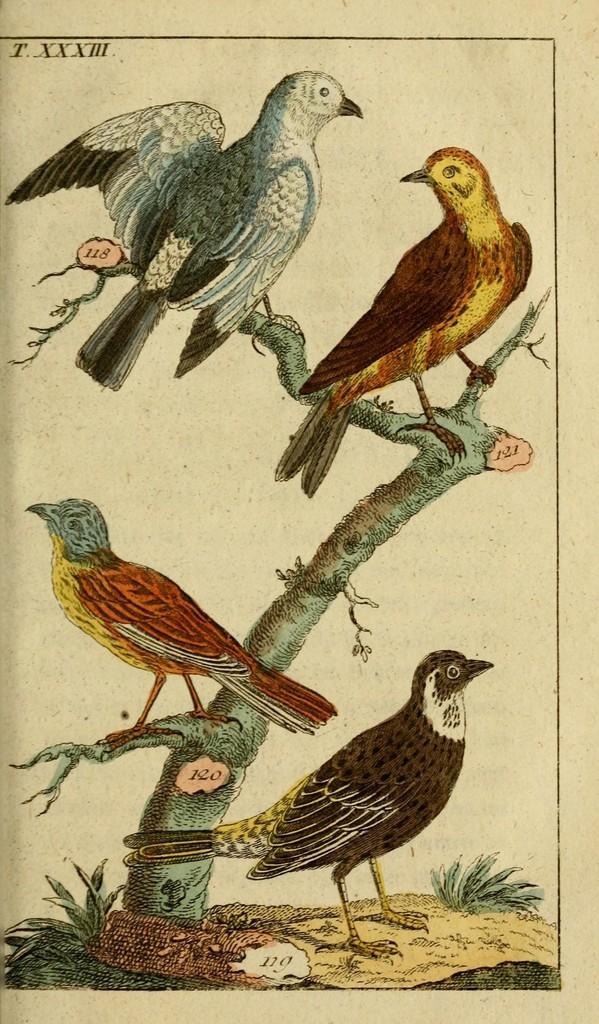Describe this image in one or two sentences. In this image, there are four birds in different colors. In the these four, three birds are on the branch. 